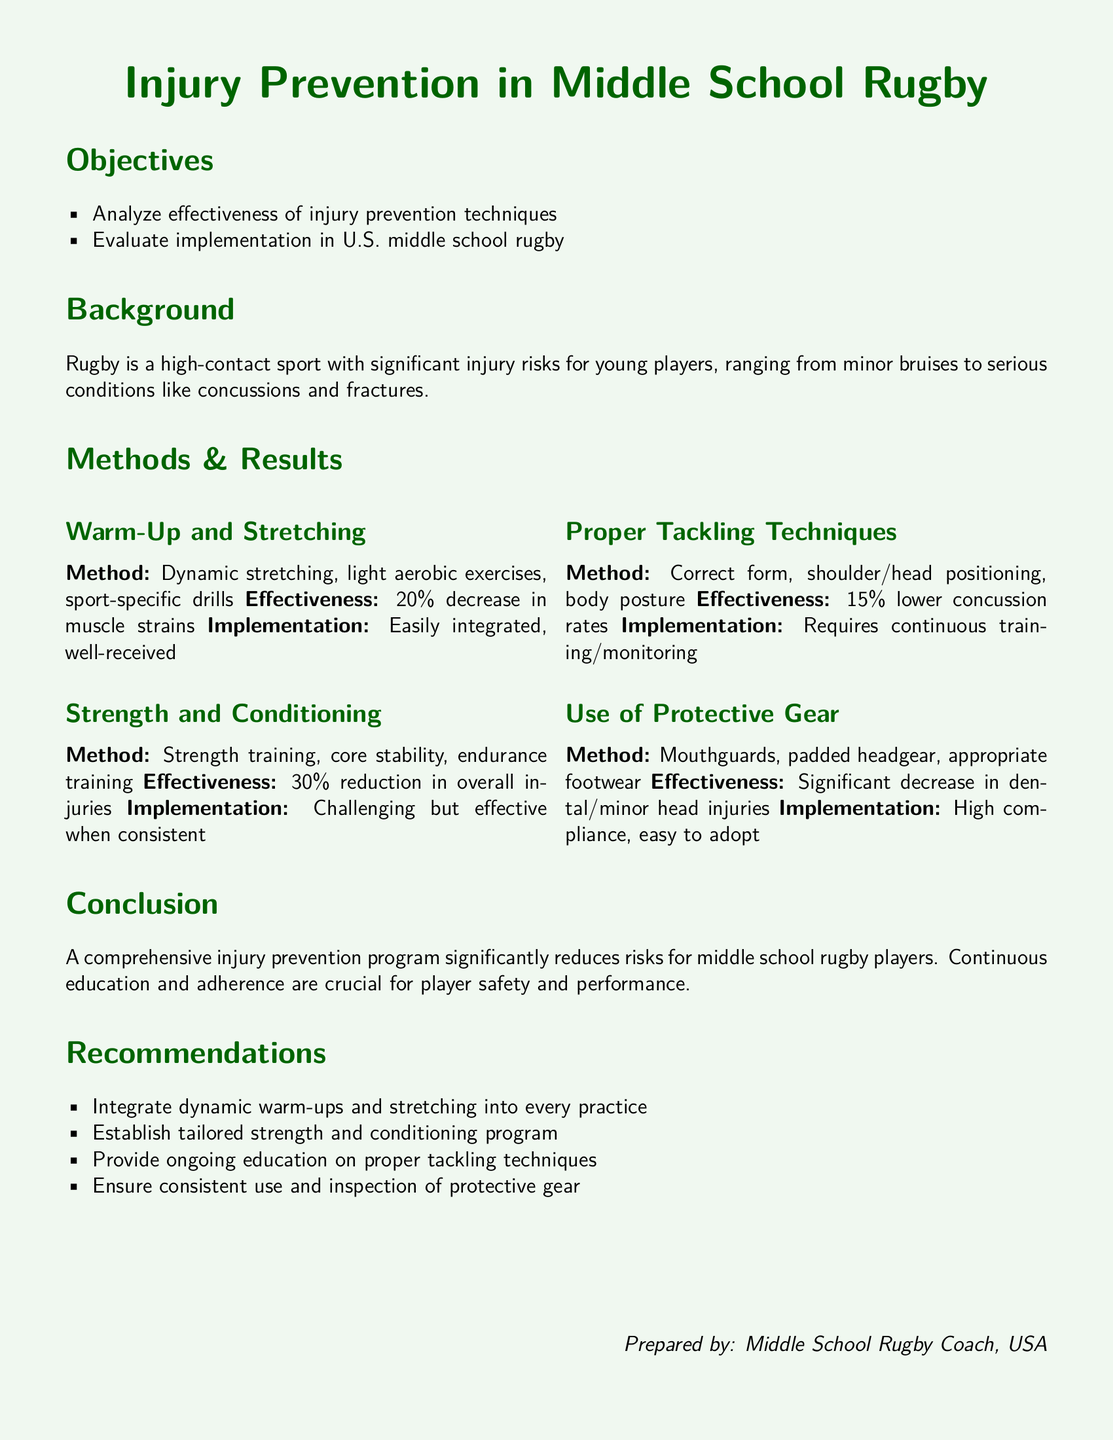what percentage decrease in muscle strains was observed? The document states a 20% decrease in muscle strains due to warm-up and stretching techniques.
Answer: 20% what was the effectiveness reduction in overall injuries from strength and conditioning? Strength and conditioning methods resulted in a 30% reduction in overall injuries.
Answer: 30% how much lower were concussion rates with proper tackling techniques? Proper tackling techniques resulted in a 15% lower concussion rate.
Answer: 15% what is the recommended warm-up technique? The recommended warm-up technique includes dynamic stretching and light aerobic exercises.
Answer: dynamic stretching what type of injuries significantly decreased with the use of protective gear? The use of protective gear led to a significant decrease in dental and minor head injuries.
Answer: dental/minor head injuries how easy was it to implement the use of protective gear? The document indicates that the implementation of protective gear had high compliance and was easy to adopt.
Answer: easy to adopt what is a crucial aspect for player safety and performance mentioned in the conclusion? The conclusion emphasizes that continuous education and adherence are crucial for player safety and performance.
Answer: continuous education and adherence what should be integrated into every practice according to the recommendations? The recommendations suggest that dynamic warm-ups and stretching should be integrated into every practice.
Answer: dynamic warm-ups and stretching what does the document specify about the requirement for proper tackling techniques? The document states that proper tackling techniques require continuous training and monitoring.
Answer: continuous training/monitoring 